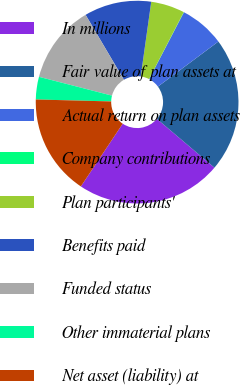Convert chart. <chart><loc_0><loc_0><loc_500><loc_500><pie_chart><fcel>In millions<fcel>Fair value of plan assets at<fcel>Actual return on plan assets<fcel>Company contributions<fcel>Plan participants'<fcel>Benefits paid<fcel>Funded status<fcel>Other immaterial plans<fcel>Net asset (liability) at<nl><fcel>23.18%<fcel>21.4%<fcel>7.16%<fcel>0.04%<fcel>5.38%<fcel>10.72%<fcel>12.5%<fcel>3.6%<fcel>16.06%<nl></chart> 